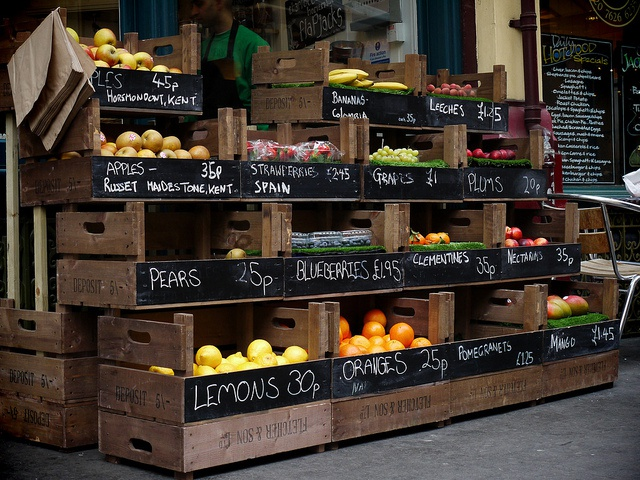Describe the objects in this image and their specific colors. I can see people in black, darkgreen, and gray tones, apple in black, tan, and olive tones, chair in black, maroon, darkgray, and gray tones, orange in black, orange, red, gold, and tan tones, and apple in black, khaki, olive, and tan tones in this image. 